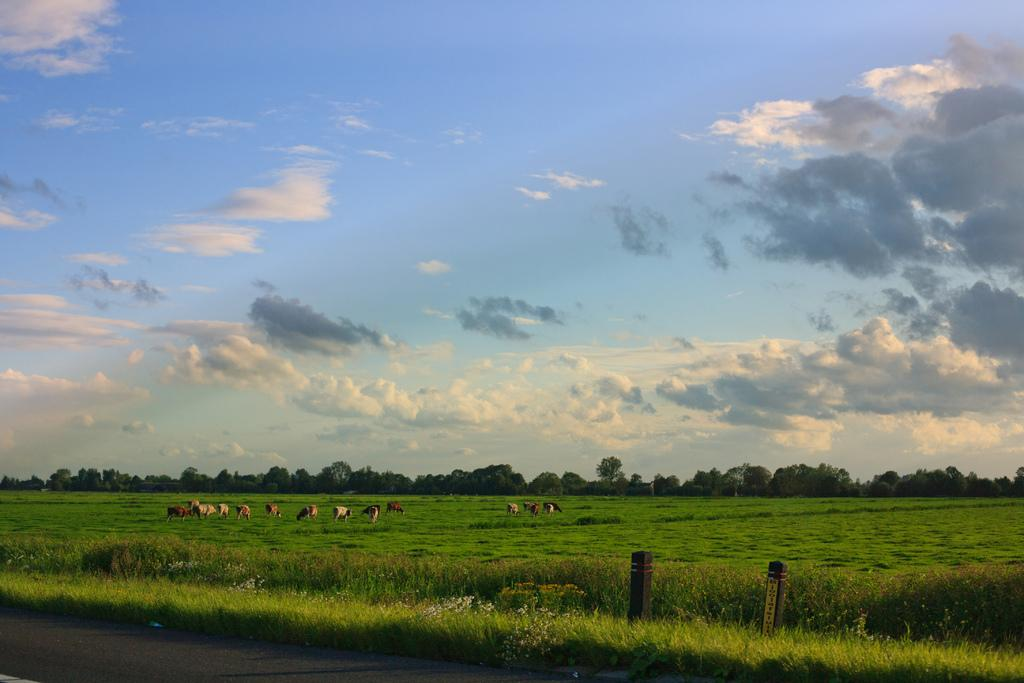What is located near the grass on the ground in the image? There is a road near the grass on the ground in the image. What are the animals in the background doing? The animals in the background are eating grass. What can be seen in the background besides the animals? There are trees in the background. What is the color of the sky in the image? The sky in the image is blue with clouds. How many cats are sitting on the zebra in the image? There are no cats or zebras present in the image. 